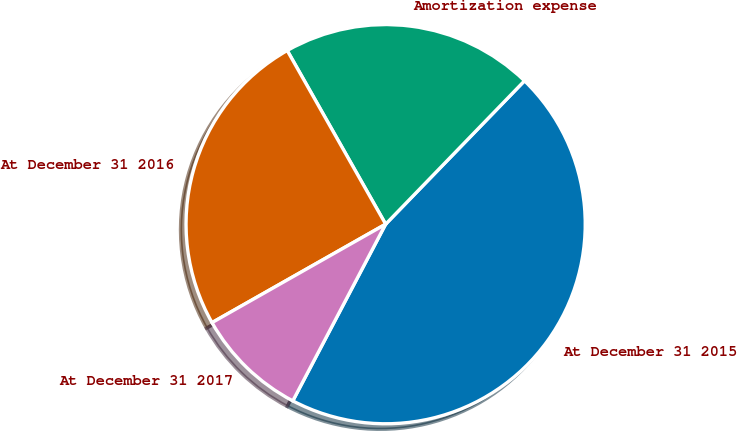Convert chart to OTSL. <chart><loc_0><loc_0><loc_500><loc_500><pie_chart><fcel>At December 31 2015<fcel>Amortization expense<fcel>At December 31 2016<fcel>At December 31 2017<nl><fcel>45.45%<fcel>20.45%<fcel>25.0%<fcel>9.09%<nl></chart> 